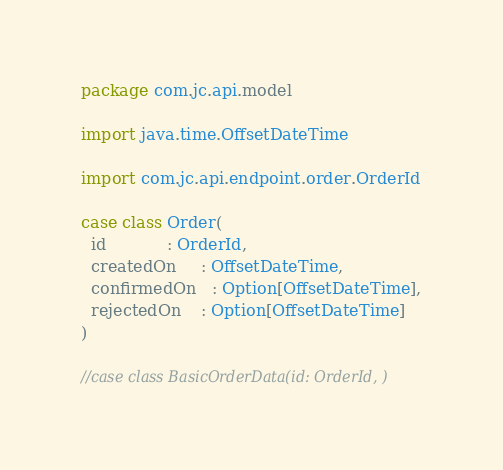<code> <loc_0><loc_0><loc_500><loc_500><_Scala_>package com.jc.api.model

import java.time.OffsetDateTime

import com.jc.api.endpoint.order.OrderId

case class Order(
  id            : OrderId,
  createdOn     : OffsetDateTime,
  confirmedOn   : Option[OffsetDateTime],
  rejectedOn    : Option[OffsetDateTime]
)

//case class BasicOrderData(id: OrderId, )</code> 